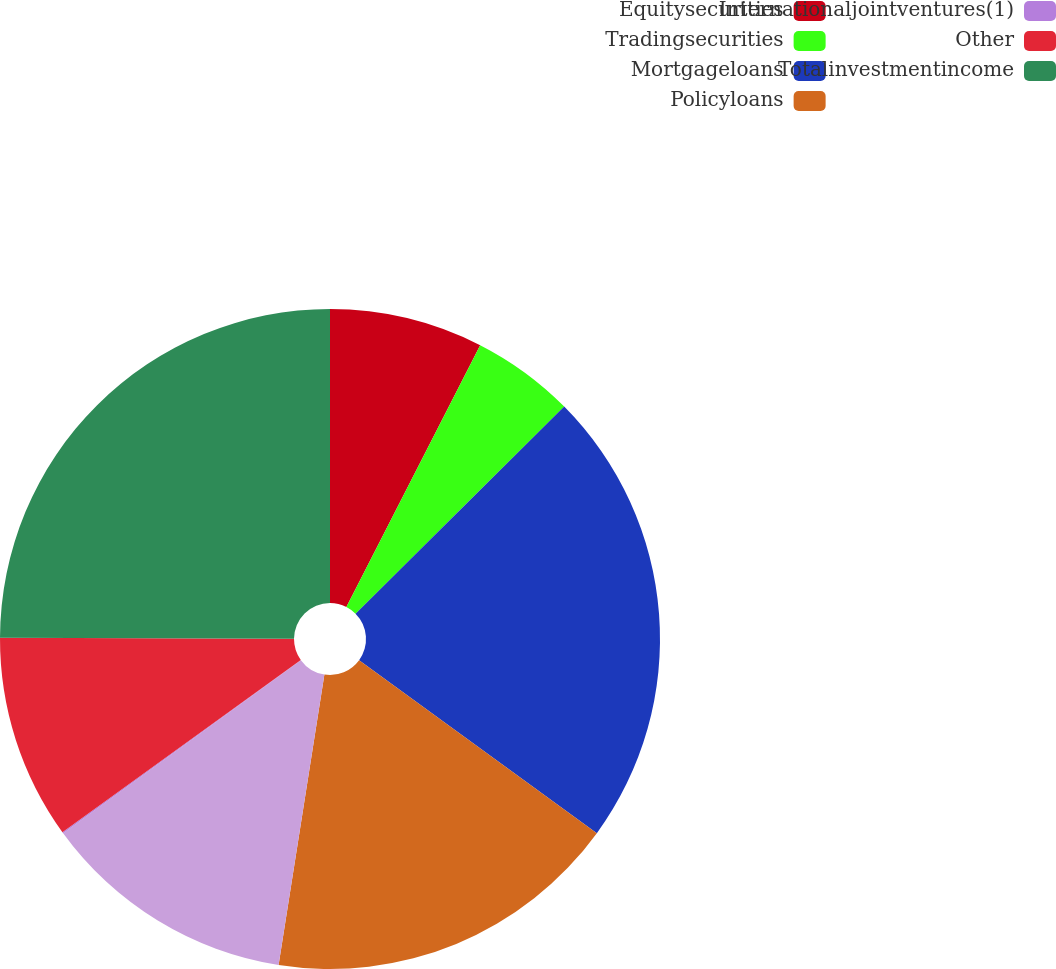<chart> <loc_0><loc_0><loc_500><loc_500><pie_chart><fcel>Equitysecurities<fcel>Tradingsecurities<fcel>Mortgageloans<fcel>Policyloans<fcel>Unnamed: 4<fcel>Internationaljointventures(1)<fcel>Other<fcel>Totalinvestmentincome<nl><fcel>7.52%<fcel>5.04%<fcel>22.45%<fcel>17.48%<fcel>12.5%<fcel>0.06%<fcel>10.01%<fcel>24.94%<nl></chart> 